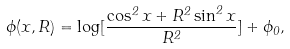Convert formula to latex. <formula><loc_0><loc_0><loc_500><loc_500>\phi ( x , R ) = \log [ \frac { \cos ^ { 2 } x + R ^ { 2 } \sin ^ { 2 } x } { R ^ { 2 } } ] + \phi _ { 0 } ,</formula> 